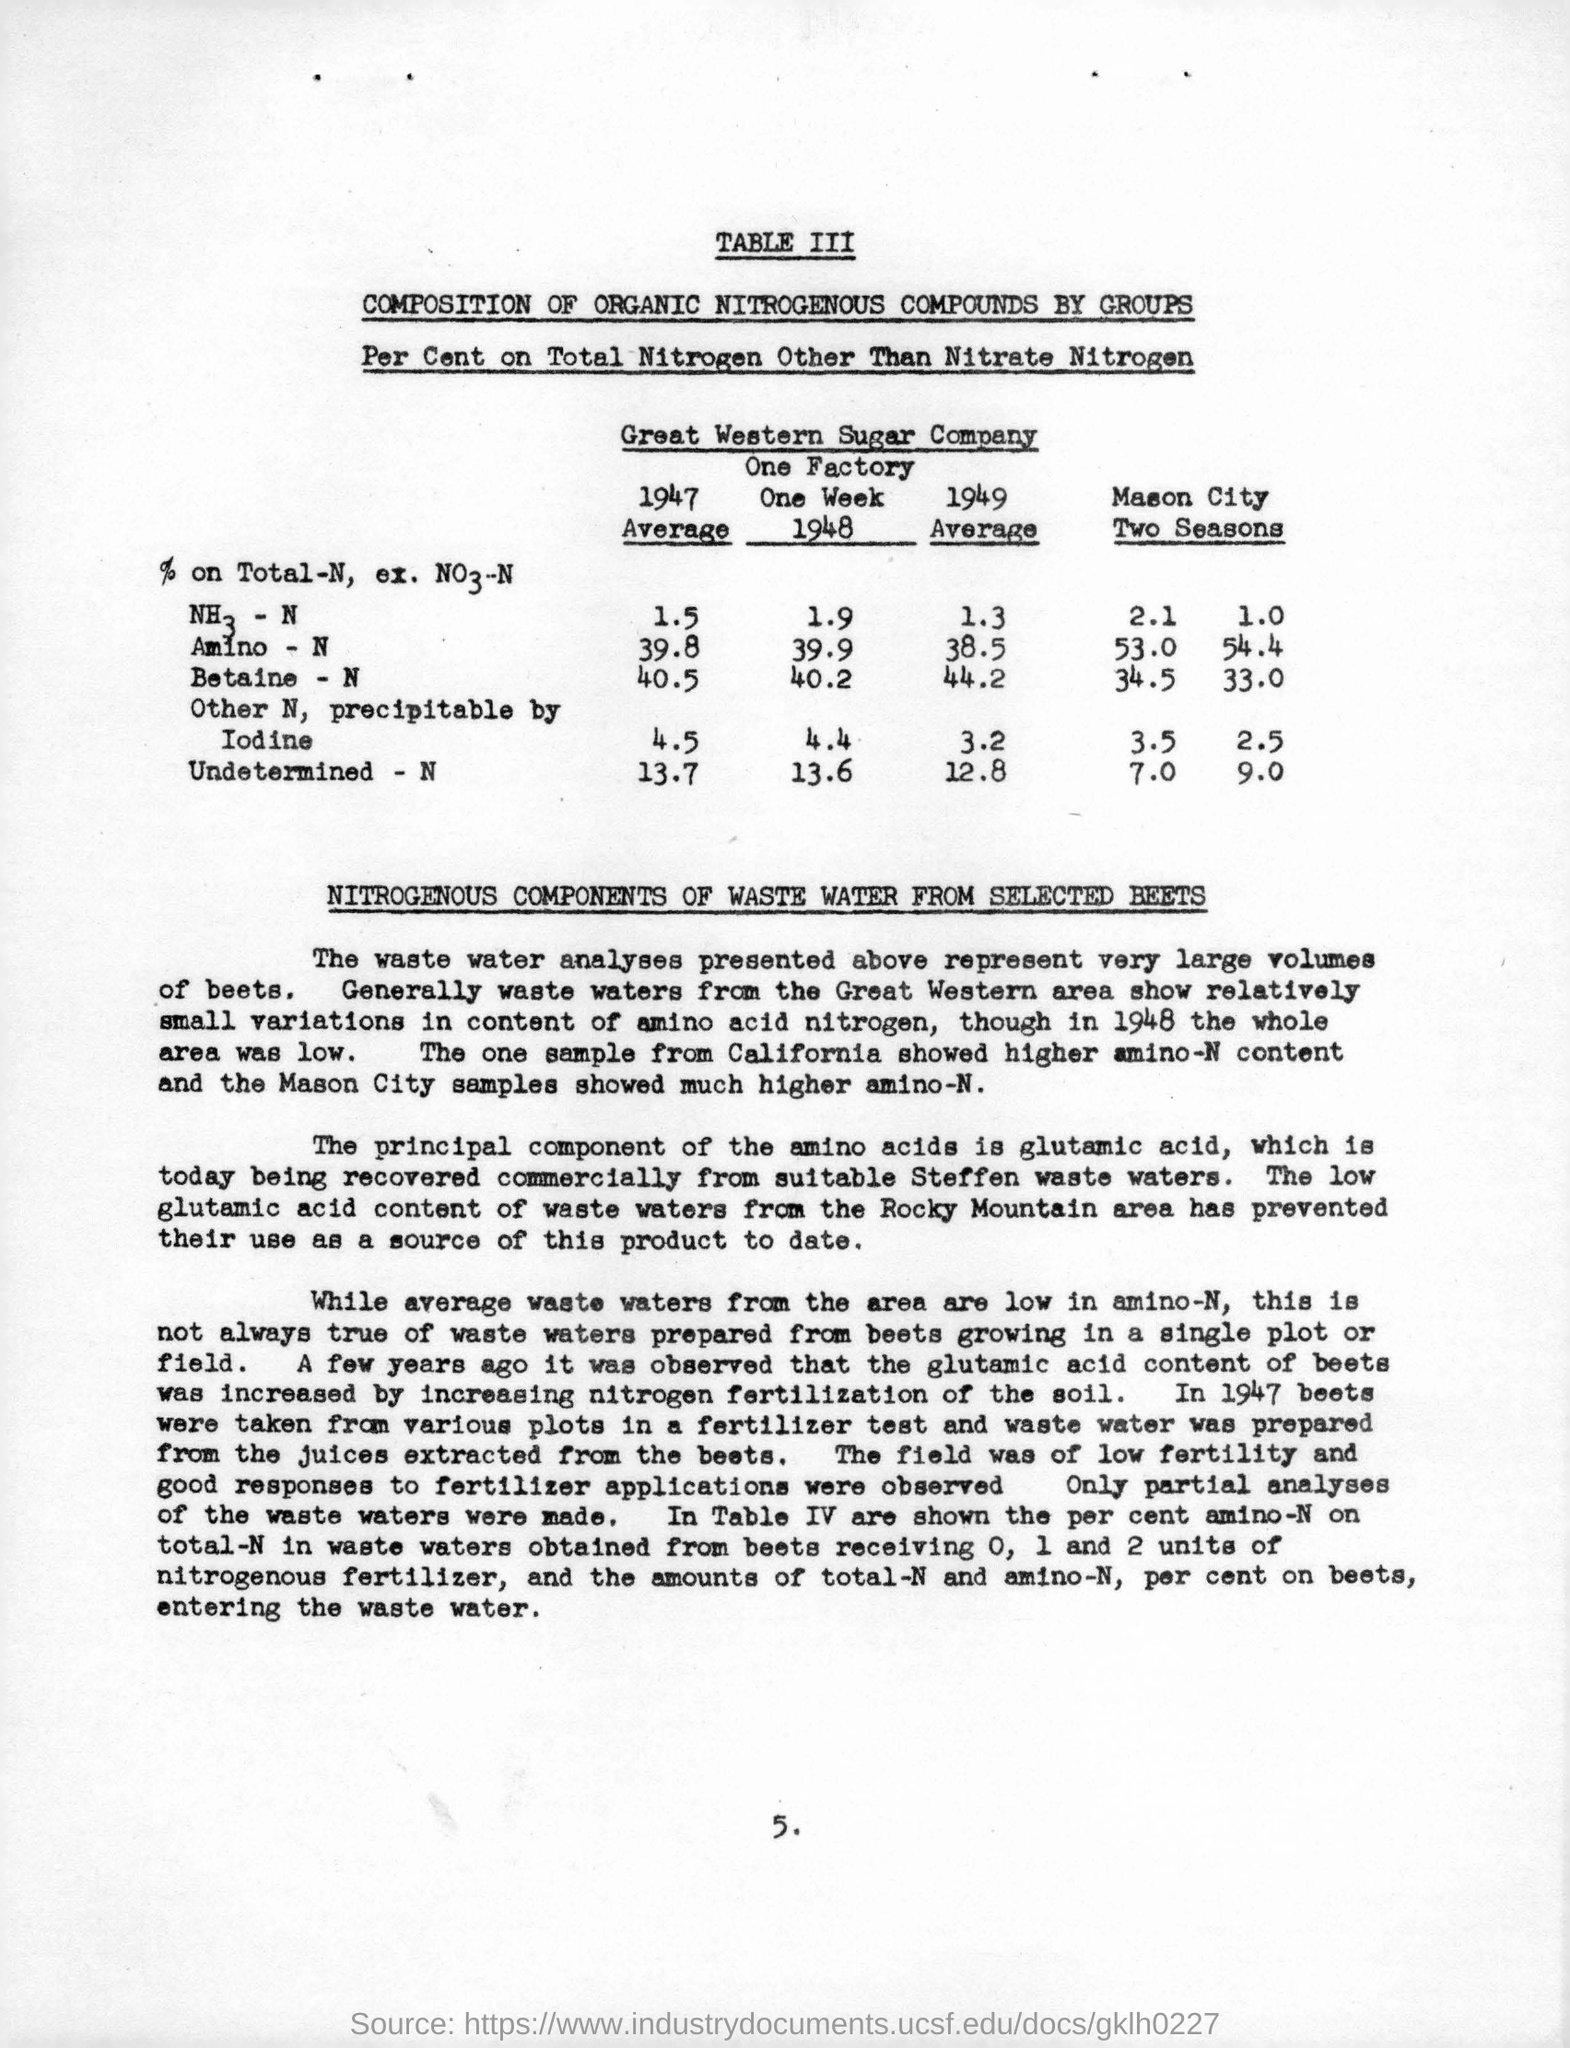What is the name of the company ?
Provide a succinct answer. Great Western Sugar Company. What is the average  % of total n in amino-n in the year 1947 ?
Provide a succinct answer. 39.8. What is the average value of betaine -n in 1949 ?
Your answer should be very brief. 44.2. What is the principal component of amino acids ?
Your answer should be compact. Glutamic acid. What is the value of iodine in mason city in second season ?
Your answer should be very brief. 2.5. 